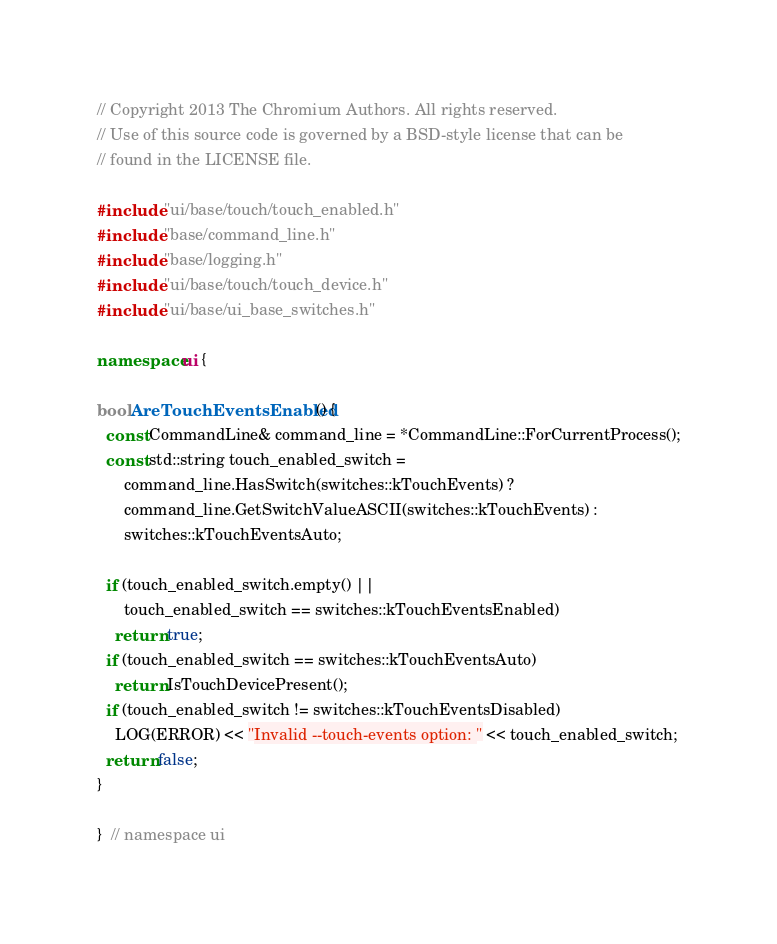Convert code to text. <code><loc_0><loc_0><loc_500><loc_500><_C++_>// Copyright 2013 The Chromium Authors. All rights reserved.
// Use of this source code is governed by a BSD-style license that can be
// found in the LICENSE file.

#include "ui/base/touch/touch_enabled.h"
#include "base/command_line.h"
#include "base/logging.h"
#include "ui/base/touch/touch_device.h"
#include "ui/base/ui_base_switches.h"

namespace ui {

bool AreTouchEventsEnabled() {
  const CommandLine& command_line = *CommandLine::ForCurrentProcess();
  const std::string touch_enabled_switch =
      command_line.HasSwitch(switches::kTouchEvents) ?
      command_line.GetSwitchValueASCII(switches::kTouchEvents) :
      switches::kTouchEventsAuto;

  if (touch_enabled_switch.empty() ||
      touch_enabled_switch == switches::kTouchEventsEnabled)
    return true;
  if (touch_enabled_switch == switches::kTouchEventsAuto)
    return IsTouchDevicePresent();
  if (touch_enabled_switch != switches::kTouchEventsDisabled)
    LOG(ERROR) << "Invalid --touch-events option: " << touch_enabled_switch;
  return false;
}

}  // namespace ui
</code> 